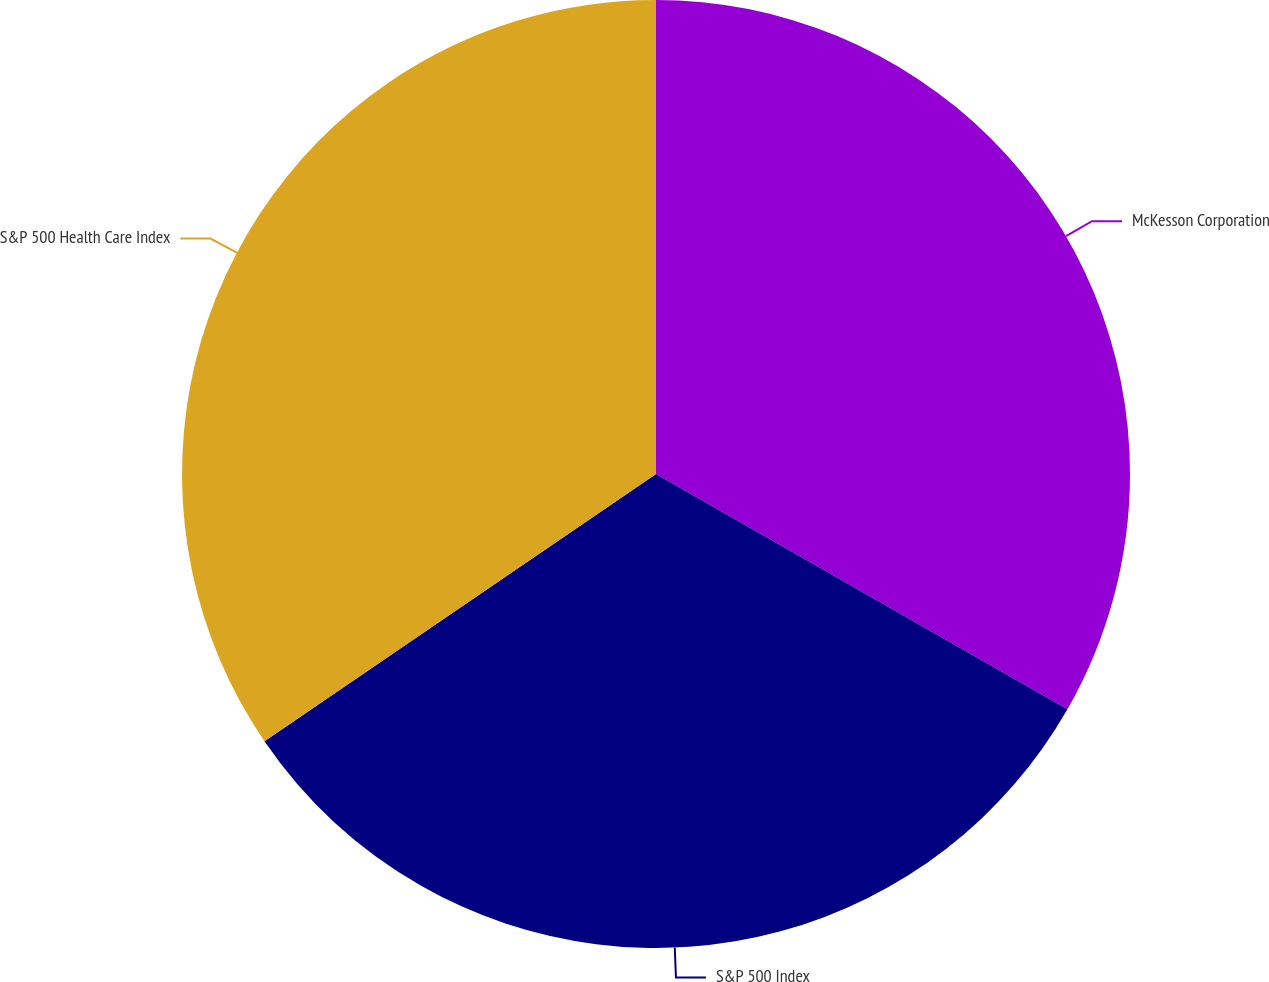<chart> <loc_0><loc_0><loc_500><loc_500><pie_chart><fcel>McKesson Corporation<fcel>S&P 500 Index<fcel>S&P 500 Health Care Index<nl><fcel>33.27%<fcel>32.2%<fcel>34.53%<nl></chart> 